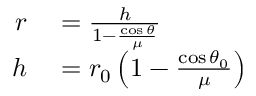<formula> <loc_0><loc_0><loc_500><loc_500>\begin{array} { r l } { r } & = { \frac { h } { 1 - { \frac { \cos { \theta } } { \mu } } } } } \\ { h } & = r _ { 0 } \left ( 1 - { \frac { \cos { \theta _ { 0 } } } { \mu } } \right ) } \end{array}</formula> 